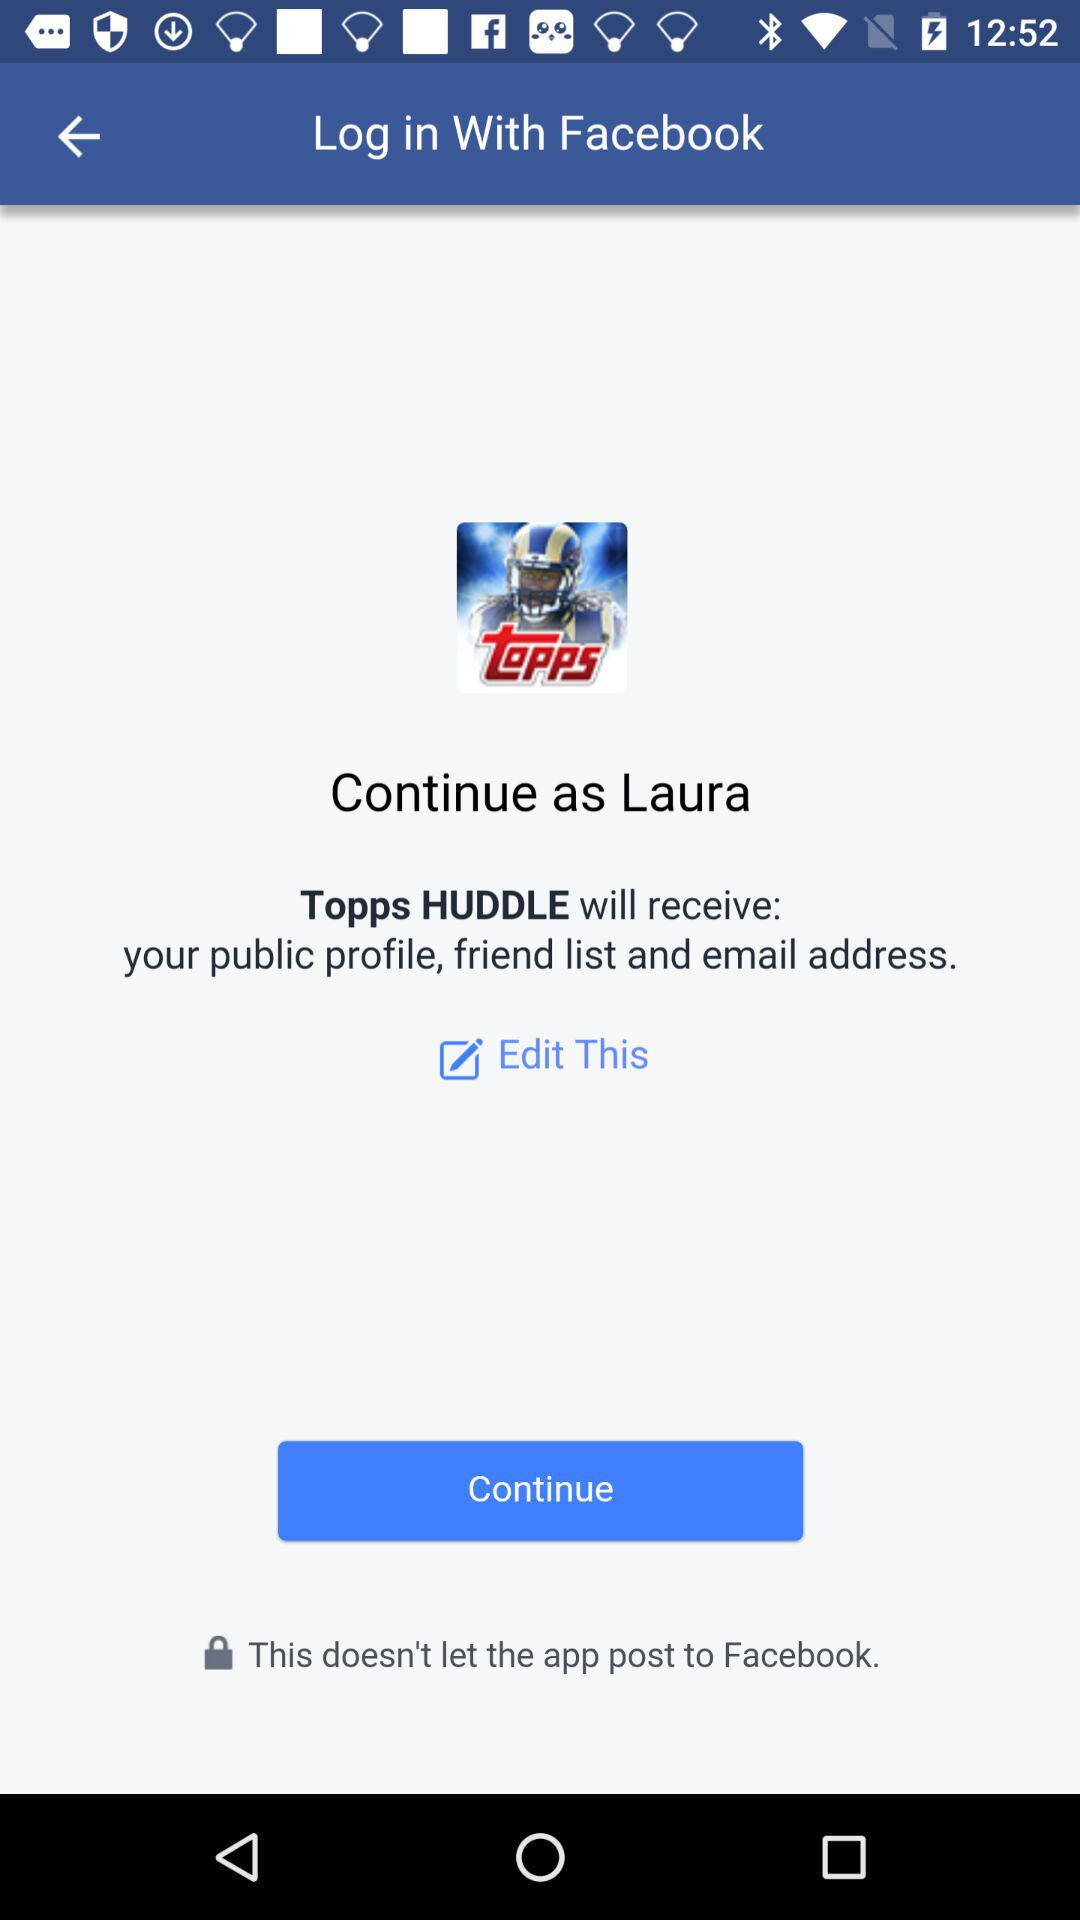What is the user name? The user name is Laura. 